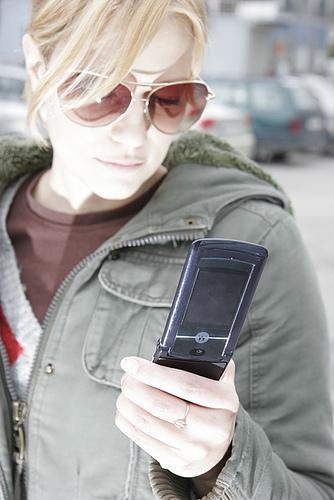What brand of phone is this?
Keep it brief. Motorola. Is she holding a smartphone?
Answer briefly. No. IS the woman wearing glasses?
Give a very brief answer. Yes. 